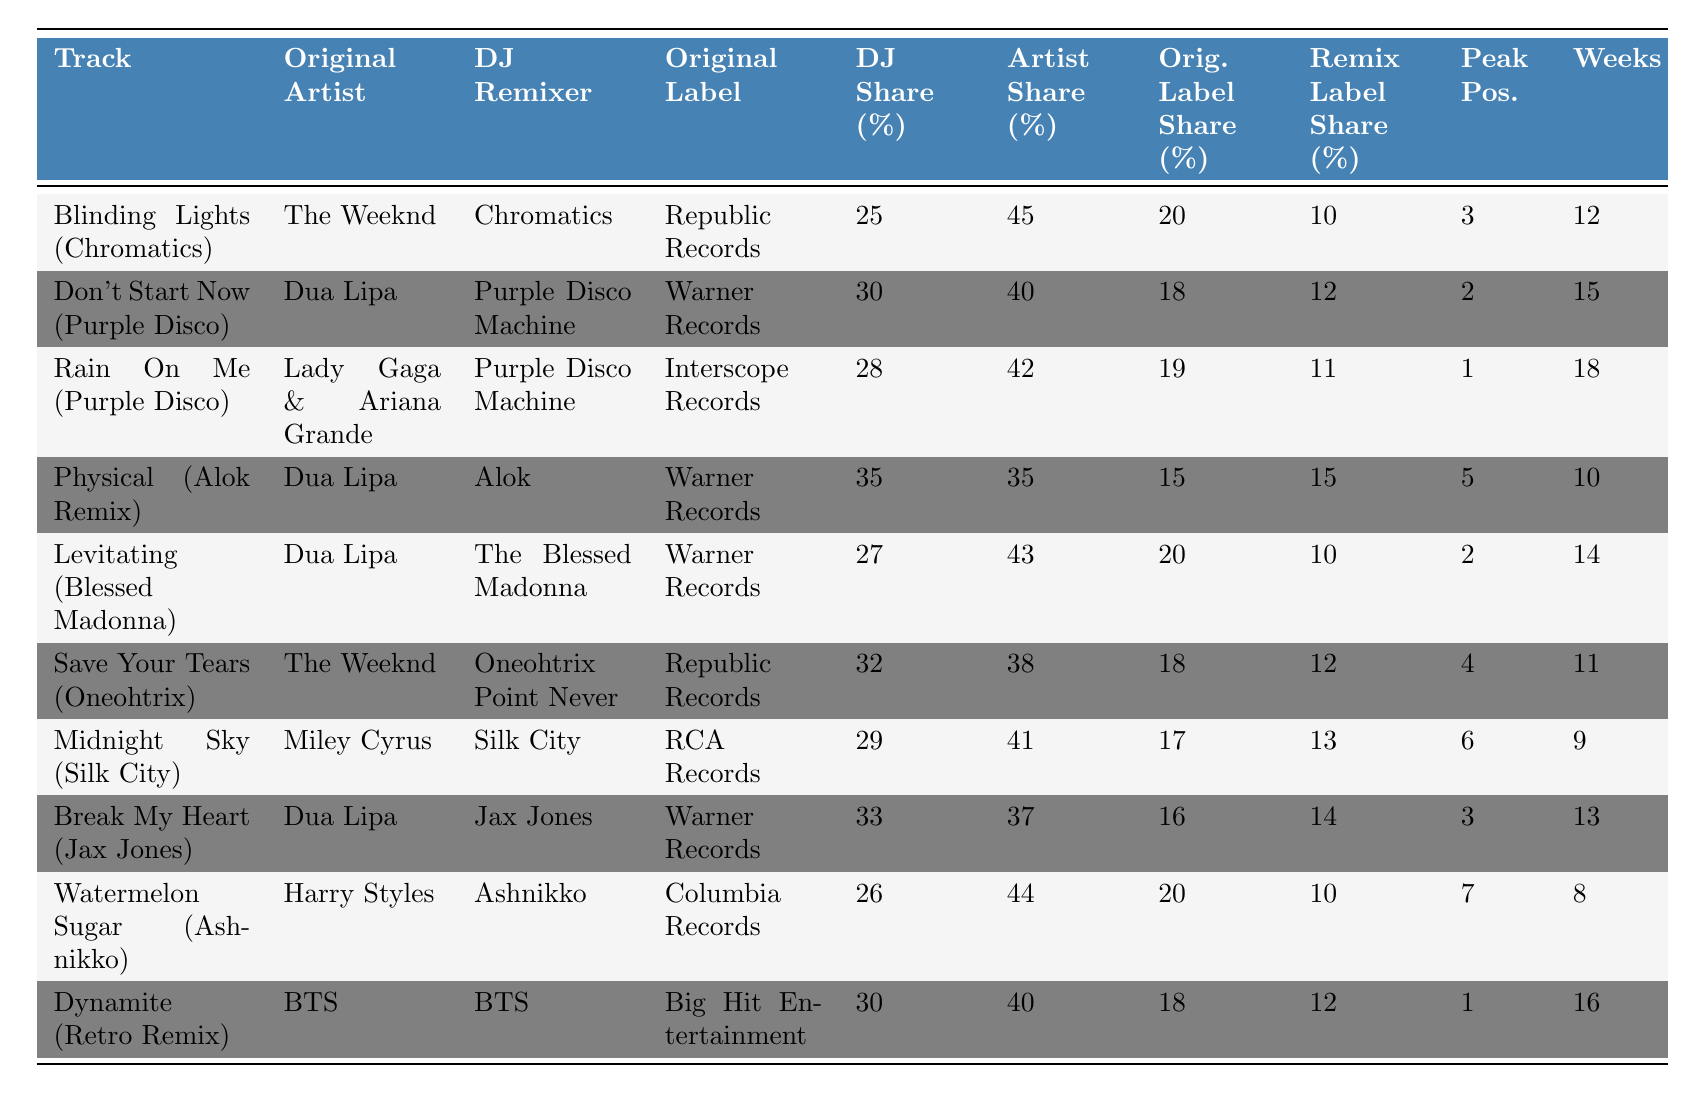What is the DJ revenue share for the remix of "Blinding Lights"? The DJ revenue share for "Blinding Lights (Chromatics Remix)" is 25%. This can be found directly in the "DJ Share (%)" column next to the track title.
Answer: 25% Which original artist has the highest revenue share among chart-topping remixes? The highest original artist revenue share in the table is 45% for the track "Blinding Lights (Chromatics Remix)" by The Weeknd. This can be seen in the "Artist Share (%)" column.
Answer: 45% What is the total revenue share for the remix label of "Don't Start Now"? The total revenue share for the remix label of "Don't Start Now (Purple Disco Machine Remix)" is 12%. This value is found in the "Remix Label Share (%)" column.
Answer: 12% Which remix has the lowest DJ revenue share? The remix with the lowest DJ revenue share is "Blinding Lights (Chromatics Remix)", which has a share of 25%. This can be determined by comparing the "DJ Share (%)" values.
Answer: 25% What is the average revenue share for the original labels? To find the average, sum the original label shares: (20 + 18 + 19 + 15 + 20 + 18 + 17 + 16 + 20 + 18) =  200. Divide by the number of tracks (10) to get 200/10 = 20.
Answer: 20% Which track has the highest peak chart position, and what is that position? The track with the highest peak chart position is "Rain On Me (Purple Disco Machine Remix)", which reached position 1. This is shown in the "Peak Pos." column.
Answer: 1 Is the DJ revenue share for "Dynamite (Retro Remix)" equal to the remix label revenue share? For "Dynamite (Retro Remix)", the DJ revenue share is 30% and the remix label revenue share is also 12%. Since these values are not equal, the answer is no.
Answer: No Which original artist has two remixes listed, and what are their DJ shares? The original artist Dua Lipa has three remixes listed: "Don't Start Now (Purple Disco Machine Remix)", "Physical (Alok Remix)", "Levitating (Blessed Madonna Remix)". Their DJ shares are 30%, 35%, and 27%, respectively.
Answer: Dua Lipa, 30%, 35%, 27% What is the total revenue share for the remix of "Midnight Sky"? The total revenue share for "Midnight Sky (Silk City Remix)" involves adding the shares: DJ (29%) + Original Artist (41%) + Original Label (17%) + Remix Label (13%) = 100%. This confirms the complete distribution.
Answer: 100% How many weeks did "Watermelon Sugar (Ashnikko Remix)" spend on the chart? "Watermelon Sugar (Ashnikko Remix)" spent 8 weeks on the chart, as indicated in the "Weeks" column.
Answer: 8 